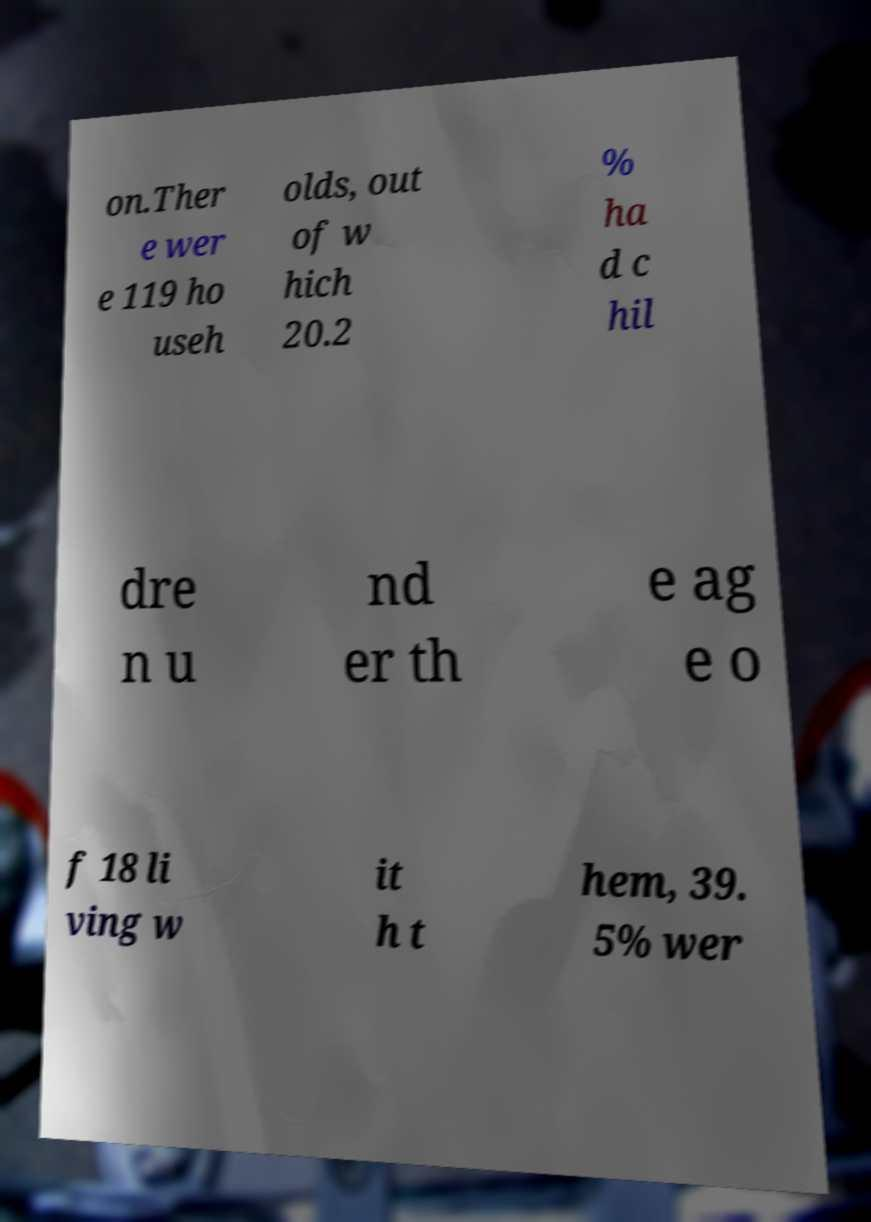Can you read and provide the text displayed in the image?This photo seems to have some interesting text. Can you extract and type it out for me? on.Ther e wer e 119 ho useh olds, out of w hich 20.2 % ha d c hil dre n u nd er th e ag e o f 18 li ving w it h t hem, 39. 5% wer 